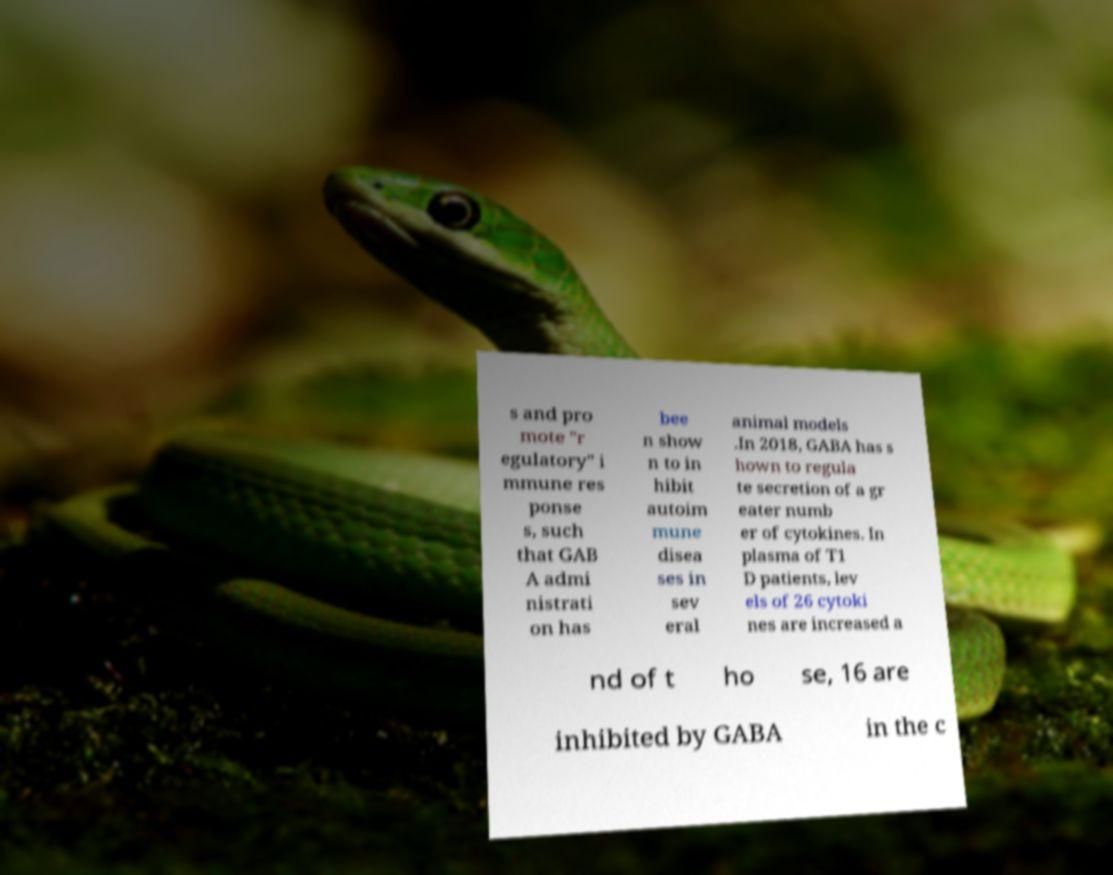Could you assist in decoding the text presented in this image and type it out clearly? s and pro mote "r egulatory" i mmune res ponse s, such that GAB A admi nistrati on has bee n show n to in hibit autoim mune disea ses in sev eral animal models .In 2018, GABA has s hown to regula te secretion of a gr eater numb er of cytokines. In plasma of T1 D patients, lev els of 26 cytoki nes are increased a nd of t ho se, 16 are inhibited by GABA in the c 